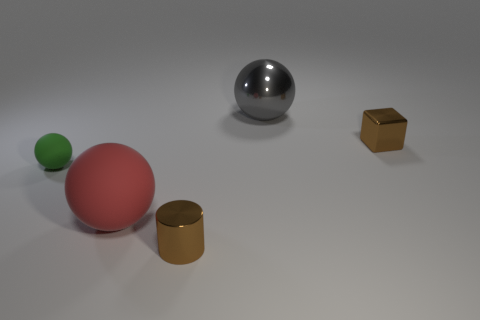What number of metallic blocks have the same color as the small metal cylinder?
Your answer should be very brief. 1. What is the color of the tiny rubber object that is the same shape as the big metallic object?
Your response must be concise. Green. There is a tiny thing that is both left of the gray shiny ball and right of the tiny green object; what shape is it?
Ensure brevity in your answer.  Cylinder. Are there more tiny shiny cylinders than tiny yellow metallic objects?
Give a very brief answer. Yes. What is the green thing made of?
Keep it short and to the point. Rubber. The red rubber thing that is the same shape as the green thing is what size?
Make the answer very short. Large. Are there any tiny green balls that are behind the small brown metal thing behind the small brown cylinder?
Make the answer very short. No. Do the tiny block and the cylinder have the same color?
Your response must be concise. Yes. How many other objects are there of the same shape as the big red rubber thing?
Make the answer very short. 2. Are there more small metal objects behind the red thing than tiny green matte objects on the right side of the gray shiny sphere?
Offer a terse response. Yes. 